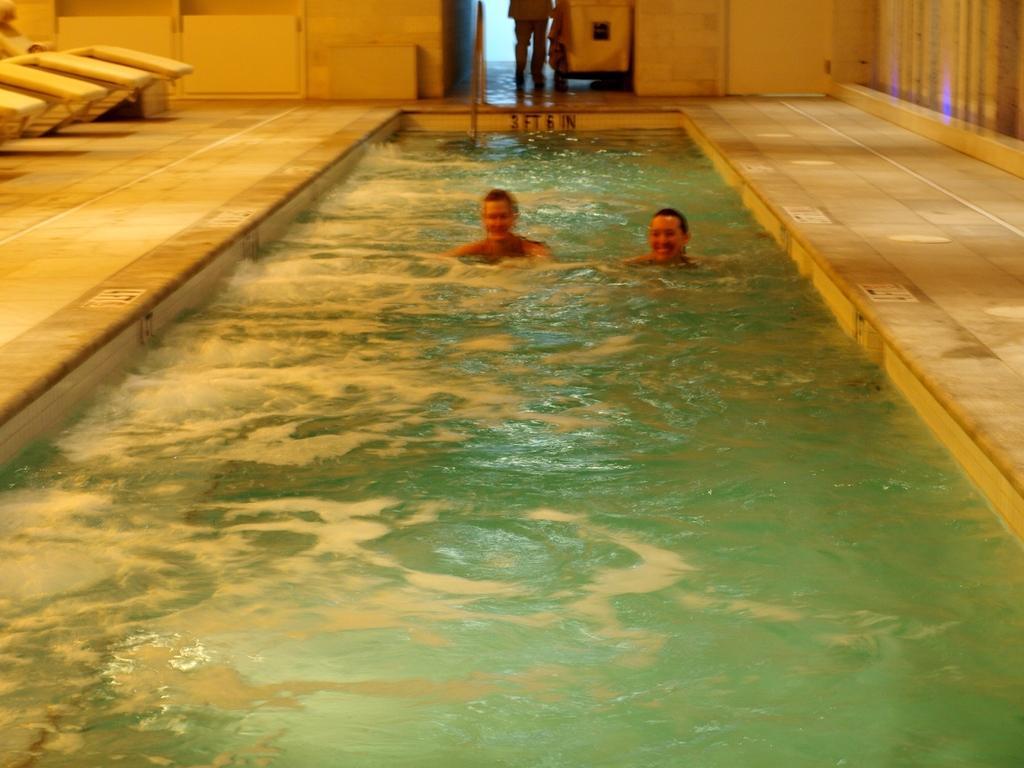In one or two sentences, can you explain what this image depicts? In the image we can see two men wearing clothes and they are swimming. Here we can see the water, floor, wall and we can even see the truncated image of the person standing and wearing clothes. 